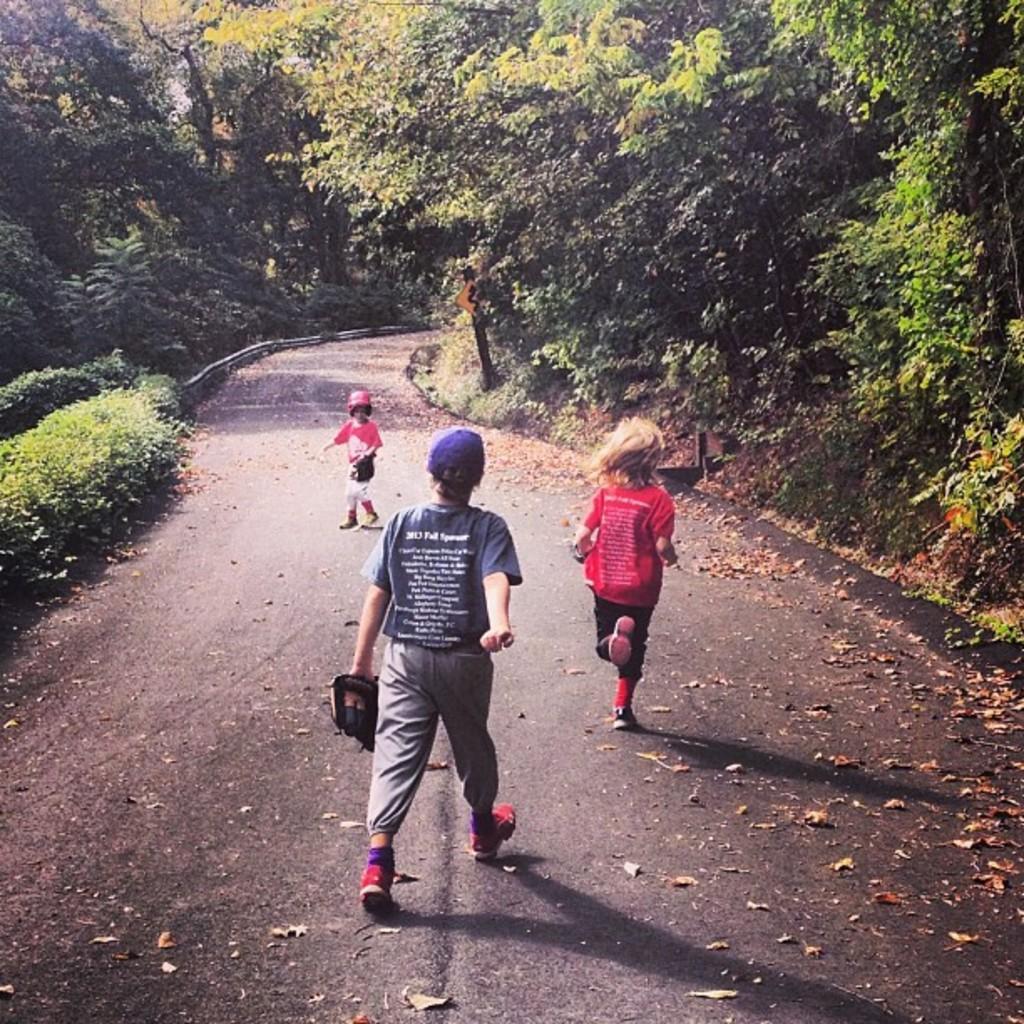In one or two sentences, can you explain what this image depicts? In this image I can see three people are walking on the road. These people are wearing the different color dresses. I can see these people are wearing the gloves. To the side of these people I can see many trees. 